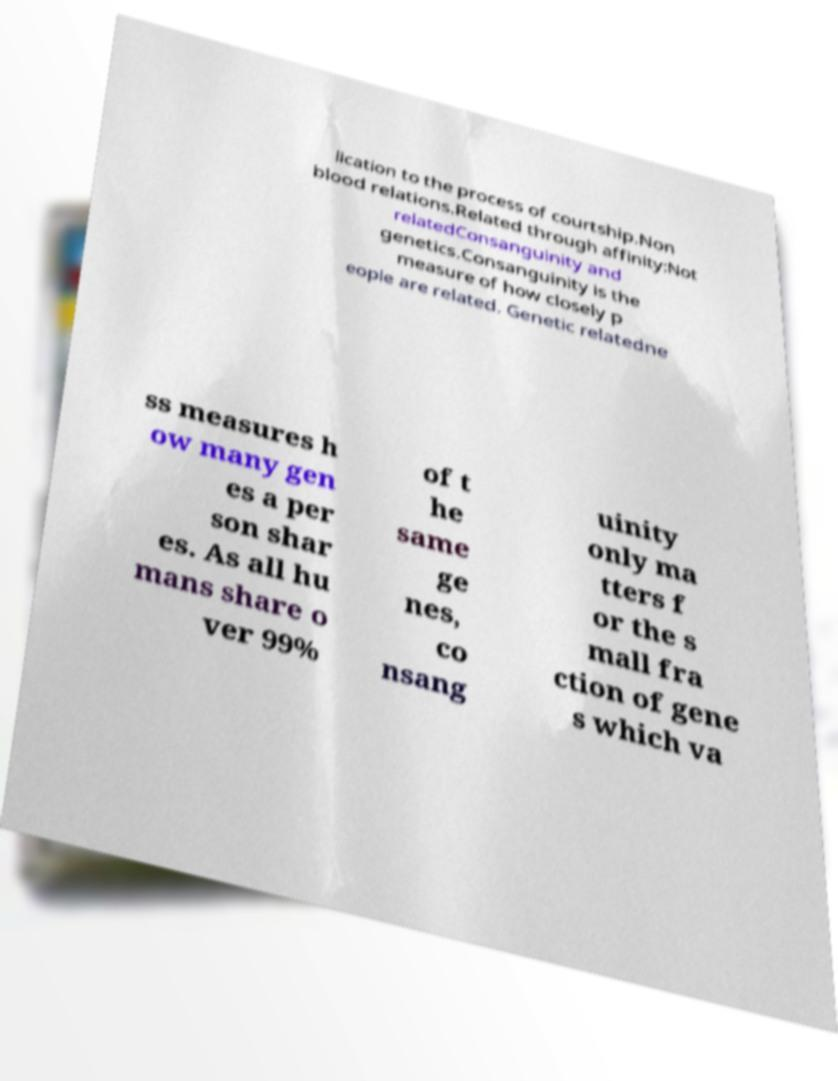Can you accurately transcribe the text from the provided image for me? lication to the process of courtship.Non blood relations.Related through affinity:Not relatedConsanguinity and genetics.Consanguinity is the measure of how closely p eople are related. Genetic relatedne ss measures h ow many gen es a per son shar es. As all hu mans share o ver 99% of t he same ge nes, co nsang uinity only ma tters f or the s mall fra ction of gene s which va 